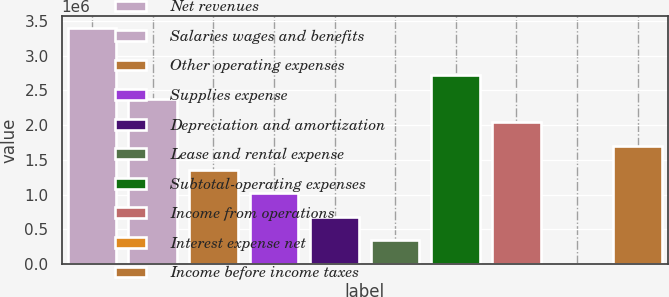<chart> <loc_0><loc_0><loc_500><loc_500><bar_chart><fcel>Net revenues<fcel>Salaries wages and benefits<fcel>Other operating expenses<fcel>Supplies expense<fcel>Depreciation and amortization<fcel>Lease and rental expense<fcel>Subtotal-operating expenses<fcel>Income from operations<fcel>Interest expense net<fcel>Income before income taxes<nl><fcel>3.3983e+06<fcel>2.37935e+06<fcel>1.36041e+06<fcel>1.02076e+06<fcel>681112<fcel>341464<fcel>2.719e+06<fcel>2.03971e+06<fcel>1816<fcel>1.70006e+06<nl></chart> 